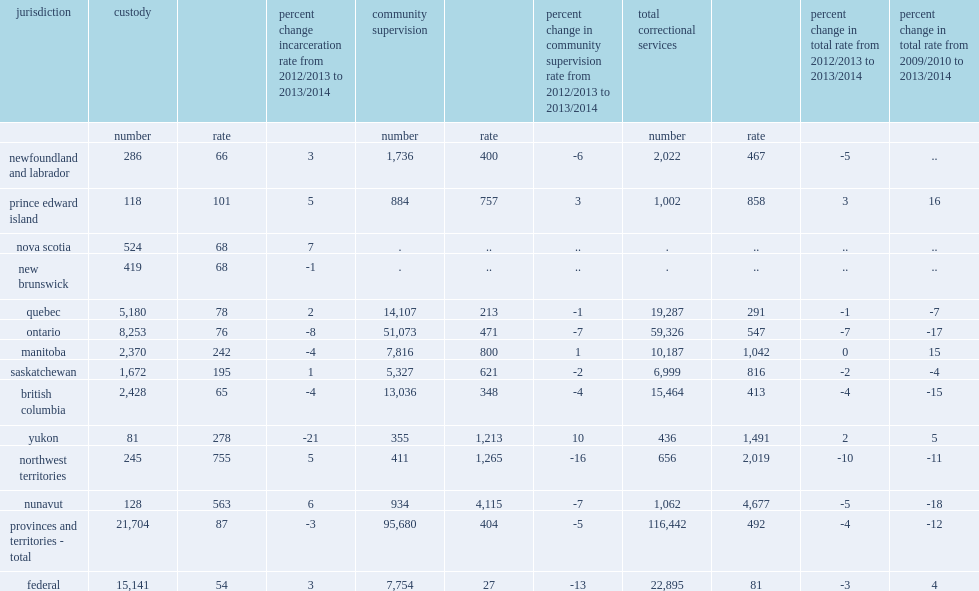In 2013/2014, on any given day, how many adult offenders are being supervised in either provincial/territorial or federal correctional services? 139337. In the 10 reporting provinces and territories for which both custody and community data were available, how many adult offenders are in either custody or a community program on a given day? 116442. What is the incarceration rate of total correctional services? 492. What are the percentage change of incarceration rate from the previous year and from five years earlier, respectively? 4 12. How many adult offenders are in the federal correctional system? 22895. What is the federal incarceration rate? 81. How many percent of the federal incarceration rate was decreased from pervious year? 3. Compared to 2009/2010, how many percent of the federal incarceration rate was increased? 4. How many percent of adults under correctional supervision in the provinces and territories in 2013/2014 were in custody? 0.186393. How many percent of adults under correctional supervision in the provinces and territories in 2013/2014 were in the community? 0.821697. In 2013/2014, how many adults are in custody on an average day? 36845. In 2013/2014, how many adult offenders are in provincial/territorial custody? 21704. In 2013/2014, how many adult offenders are in federal custody? 15141. What is the provincial/territorial incarceration rate for custody? 87. How many percent of the provincial/territorial incarceration rate for custody is decreased from previous year? 3. How many percent of the federal incarceration rate for custody is increased from the previous year to 54 offenders per 100,000 adult population? 3. How many provinces and territories has reported a decreasing incarceration rate for custody only among 12 reporting provinces and territories? 5. Which province has the highest rate of incarceration in custody at 242 per 100,000 adult population? Manitoba. Which province has the lowest incarceration rate in custody? British columbia. On any given day in 2013/2014, in the 10 provinces and territories for which community data were reported, how many adult offenders are being supervised through community programs? 95680. How many offenders are being supervised by correctional service canada on day parole, full parole, or statutory release? 7754. In provincial/territorial corrections, what is the rate of adult offenders being supervised in the community stood in 2013/2014? 404. In provincial/territorial corrections, how many percent point of the rate of adult being supervised in community stood has decreased from the previous year? 5. How many percent point of the rate of federal offenders in community supervision has declined to a rate of 27 adults per 100,000 population? 13. 